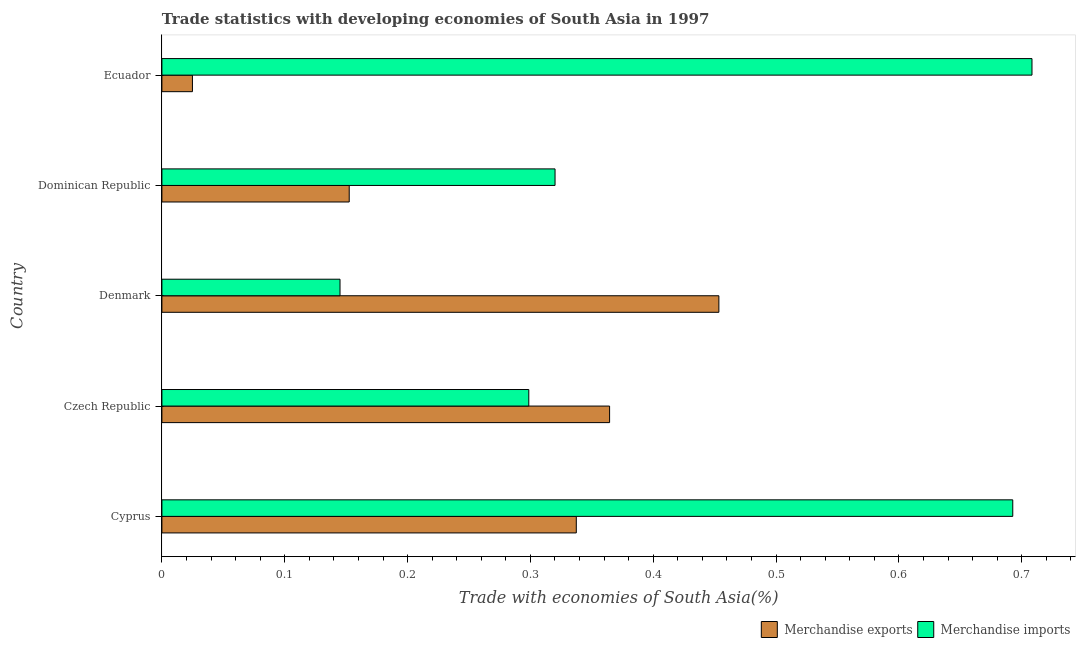How many different coloured bars are there?
Provide a short and direct response. 2. How many groups of bars are there?
Keep it short and to the point. 5. What is the label of the 2nd group of bars from the top?
Provide a succinct answer. Dominican Republic. What is the merchandise imports in Ecuador?
Offer a very short reply. 0.71. Across all countries, what is the maximum merchandise exports?
Offer a terse response. 0.45. Across all countries, what is the minimum merchandise exports?
Make the answer very short. 0.02. In which country was the merchandise imports maximum?
Offer a very short reply. Ecuador. In which country was the merchandise exports minimum?
Offer a terse response. Ecuador. What is the total merchandise imports in the graph?
Your answer should be very brief. 2.16. What is the difference between the merchandise imports in Cyprus and that in Dominican Republic?
Provide a short and direct response. 0.37. What is the difference between the merchandise exports in Czech Republic and the merchandise imports in Dominican Republic?
Provide a succinct answer. 0.04. What is the average merchandise exports per country?
Provide a short and direct response. 0.27. What is the difference between the merchandise imports and merchandise exports in Denmark?
Keep it short and to the point. -0.31. What is the ratio of the merchandise exports in Dominican Republic to that in Ecuador?
Offer a terse response. 6.13. Is the difference between the merchandise imports in Cyprus and Czech Republic greater than the difference between the merchandise exports in Cyprus and Czech Republic?
Ensure brevity in your answer.  Yes. What is the difference between the highest and the second highest merchandise imports?
Offer a terse response. 0.02. What is the difference between the highest and the lowest merchandise imports?
Make the answer very short. 0.56. Is the sum of the merchandise imports in Dominican Republic and Ecuador greater than the maximum merchandise exports across all countries?
Provide a short and direct response. Yes. What does the 2nd bar from the top in Denmark represents?
Provide a succinct answer. Merchandise exports. How many bars are there?
Your answer should be compact. 10. Are all the bars in the graph horizontal?
Your response must be concise. Yes. What is the difference between two consecutive major ticks on the X-axis?
Your answer should be very brief. 0.1. Are the values on the major ticks of X-axis written in scientific E-notation?
Keep it short and to the point. No. Does the graph contain any zero values?
Your answer should be very brief. No. How many legend labels are there?
Ensure brevity in your answer.  2. What is the title of the graph?
Provide a short and direct response. Trade statistics with developing economies of South Asia in 1997. What is the label or title of the X-axis?
Provide a succinct answer. Trade with economies of South Asia(%). What is the label or title of the Y-axis?
Keep it short and to the point. Country. What is the Trade with economies of South Asia(%) of Merchandise exports in Cyprus?
Keep it short and to the point. 0.34. What is the Trade with economies of South Asia(%) in Merchandise imports in Cyprus?
Make the answer very short. 0.69. What is the Trade with economies of South Asia(%) in Merchandise exports in Czech Republic?
Make the answer very short. 0.36. What is the Trade with economies of South Asia(%) in Merchandise imports in Czech Republic?
Provide a succinct answer. 0.3. What is the Trade with economies of South Asia(%) of Merchandise exports in Denmark?
Keep it short and to the point. 0.45. What is the Trade with economies of South Asia(%) in Merchandise imports in Denmark?
Your response must be concise. 0.15. What is the Trade with economies of South Asia(%) of Merchandise exports in Dominican Republic?
Offer a terse response. 0.15. What is the Trade with economies of South Asia(%) in Merchandise imports in Dominican Republic?
Make the answer very short. 0.32. What is the Trade with economies of South Asia(%) of Merchandise exports in Ecuador?
Offer a very short reply. 0.02. What is the Trade with economies of South Asia(%) of Merchandise imports in Ecuador?
Offer a very short reply. 0.71. Across all countries, what is the maximum Trade with economies of South Asia(%) in Merchandise exports?
Ensure brevity in your answer.  0.45. Across all countries, what is the maximum Trade with economies of South Asia(%) of Merchandise imports?
Provide a succinct answer. 0.71. Across all countries, what is the minimum Trade with economies of South Asia(%) in Merchandise exports?
Provide a short and direct response. 0.02. Across all countries, what is the minimum Trade with economies of South Asia(%) of Merchandise imports?
Offer a terse response. 0.15. What is the total Trade with economies of South Asia(%) of Merchandise exports in the graph?
Your answer should be very brief. 1.33. What is the total Trade with economies of South Asia(%) in Merchandise imports in the graph?
Your answer should be compact. 2.16. What is the difference between the Trade with economies of South Asia(%) of Merchandise exports in Cyprus and that in Czech Republic?
Keep it short and to the point. -0.03. What is the difference between the Trade with economies of South Asia(%) of Merchandise imports in Cyprus and that in Czech Republic?
Your response must be concise. 0.39. What is the difference between the Trade with economies of South Asia(%) of Merchandise exports in Cyprus and that in Denmark?
Ensure brevity in your answer.  -0.12. What is the difference between the Trade with economies of South Asia(%) in Merchandise imports in Cyprus and that in Denmark?
Offer a very short reply. 0.55. What is the difference between the Trade with economies of South Asia(%) of Merchandise exports in Cyprus and that in Dominican Republic?
Your answer should be compact. 0.18. What is the difference between the Trade with economies of South Asia(%) of Merchandise imports in Cyprus and that in Dominican Republic?
Your answer should be very brief. 0.37. What is the difference between the Trade with economies of South Asia(%) of Merchandise exports in Cyprus and that in Ecuador?
Make the answer very short. 0.31. What is the difference between the Trade with economies of South Asia(%) of Merchandise imports in Cyprus and that in Ecuador?
Your answer should be very brief. -0.02. What is the difference between the Trade with economies of South Asia(%) in Merchandise exports in Czech Republic and that in Denmark?
Offer a terse response. -0.09. What is the difference between the Trade with economies of South Asia(%) of Merchandise imports in Czech Republic and that in Denmark?
Your answer should be compact. 0.15. What is the difference between the Trade with economies of South Asia(%) of Merchandise exports in Czech Republic and that in Dominican Republic?
Make the answer very short. 0.21. What is the difference between the Trade with economies of South Asia(%) of Merchandise imports in Czech Republic and that in Dominican Republic?
Keep it short and to the point. -0.02. What is the difference between the Trade with economies of South Asia(%) in Merchandise exports in Czech Republic and that in Ecuador?
Provide a short and direct response. 0.34. What is the difference between the Trade with economies of South Asia(%) in Merchandise imports in Czech Republic and that in Ecuador?
Offer a terse response. -0.41. What is the difference between the Trade with economies of South Asia(%) of Merchandise exports in Denmark and that in Dominican Republic?
Make the answer very short. 0.3. What is the difference between the Trade with economies of South Asia(%) in Merchandise imports in Denmark and that in Dominican Republic?
Provide a succinct answer. -0.18. What is the difference between the Trade with economies of South Asia(%) of Merchandise exports in Denmark and that in Ecuador?
Your response must be concise. 0.43. What is the difference between the Trade with economies of South Asia(%) in Merchandise imports in Denmark and that in Ecuador?
Your answer should be very brief. -0.56. What is the difference between the Trade with economies of South Asia(%) of Merchandise exports in Dominican Republic and that in Ecuador?
Offer a terse response. 0.13. What is the difference between the Trade with economies of South Asia(%) of Merchandise imports in Dominican Republic and that in Ecuador?
Provide a short and direct response. -0.39. What is the difference between the Trade with economies of South Asia(%) in Merchandise exports in Cyprus and the Trade with economies of South Asia(%) in Merchandise imports in Czech Republic?
Your answer should be very brief. 0.04. What is the difference between the Trade with economies of South Asia(%) in Merchandise exports in Cyprus and the Trade with economies of South Asia(%) in Merchandise imports in Denmark?
Your response must be concise. 0.19. What is the difference between the Trade with economies of South Asia(%) in Merchandise exports in Cyprus and the Trade with economies of South Asia(%) in Merchandise imports in Dominican Republic?
Give a very brief answer. 0.02. What is the difference between the Trade with economies of South Asia(%) of Merchandise exports in Cyprus and the Trade with economies of South Asia(%) of Merchandise imports in Ecuador?
Make the answer very short. -0.37. What is the difference between the Trade with economies of South Asia(%) of Merchandise exports in Czech Republic and the Trade with economies of South Asia(%) of Merchandise imports in Denmark?
Your answer should be compact. 0.22. What is the difference between the Trade with economies of South Asia(%) in Merchandise exports in Czech Republic and the Trade with economies of South Asia(%) in Merchandise imports in Dominican Republic?
Make the answer very short. 0.04. What is the difference between the Trade with economies of South Asia(%) of Merchandise exports in Czech Republic and the Trade with economies of South Asia(%) of Merchandise imports in Ecuador?
Give a very brief answer. -0.34. What is the difference between the Trade with economies of South Asia(%) in Merchandise exports in Denmark and the Trade with economies of South Asia(%) in Merchandise imports in Dominican Republic?
Keep it short and to the point. 0.13. What is the difference between the Trade with economies of South Asia(%) of Merchandise exports in Denmark and the Trade with economies of South Asia(%) of Merchandise imports in Ecuador?
Provide a succinct answer. -0.25. What is the difference between the Trade with economies of South Asia(%) in Merchandise exports in Dominican Republic and the Trade with economies of South Asia(%) in Merchandise imports in Ecuador?
Your answer should be very brief. -0.56. What is the average Trade with economies of South Asia(%) of Merchandise exports per country?
Your response must be concise. 0.27. What is the average Trade with economies of South Asia(%) in Merchandise imports per country?
Your response must be concise. 0.43. What is the difference between the Trade with economies of South Asia(%) in Merchandise exports and Trade with economies of South Asia(%) in Merchandise imports in Cyprus?
Your answer should be compact. -0.36. What is the difference between the Trade with economies of South Asia(%) in Merchandise exports and Trade with economies of South Asia(%) in Merchandise imports in Czech Republic?
Provide a short and direct response. 0.07. What is the difference between the Trade with economies of South Asia(%) of Merchandise exports and Trade with economies of South Asia(%) of Merchandise imports in Denmark?
Make the answer very short. 0.31. What is the difference between the Trade with economies of South Asia(%) of Merchandise exports and Trade with economies of South Asia(%) of Merchandise imports in Dominican Republic?
Your answer should be very brief. -0.17. What is the difference between the Trade with economies of South Asia(%) of Merchandise exports and Trade with economies of South Asia(%) of Merchandise imports in Ecuador?
Ensure brevity in your answer.  -0.68. What is the ratio of the Trade with economies of South Asia(%) in Merchandise exports in Cyprus to that in Czech Republic?
Give a very brief answer. 0.93. What is the ratio of the Trade with economies of South Asia(%) of Merchandise imports in Cyprus to that in Czech Republic?
Give a very brief answer. 2.32. What is the ratio of the Trade with economies of South Asia(%) of Merchandise exports in Cyprus to that in Denmark?
Give a very brief answer. 0.74. What is the ratio of the Trade with economies of South Asia(%) in Merchandise imports in Cyprus to that in Denmark?
Make the answer very short. 4.78. What is the ratio of the Trade with economies of South Asia(%) in Merchandise exports in Cyprus to that in Dominican Republic?
Your answer should be compact. 2.21. What is the ratio of the Trade with economies of South Asia(%) of Merchandise imports in Cyprus to that in Dominican Republic?
Provide a succinct answer. 2.16. What is the ratio of the Trade with economies of South Asia(%) of Merchandise exports in Cyprus to that in Ecuador?
Your response must be concise. 13.57. What is the ratio of the Trade with economies of South Asia(%) in Merchandise imports in Cyprus to that in Ecuador?
Offer a terse response. 0.98. What is the ratio of the Trade with economies of South Asia(%) in Merchandise exports in Czech Republic to that in Denmark?
Offer a very short reply. 0.8. What is the ratio of the Trade with economies of South Asia(%) of Merchandise imports in Czech Republic to that in Denmark?
Give a very brief answer. 2.06. What is the ratio of the Trade with economies of South Asia(%) of Merchandise exports in Czech Republic to that in Dominican Republic?
Your answer should be very brief. 2.39. What is the ratio of the Trade with economies of South Asia(%) of Merchandise imports in Czech Republic to that in Dominican Republic?
Your answer should be compact. 0.93. What is the ratio of the Trade with economies of South Asia(%) of Merchandise exports in Czech Republic to that in Ecuador?
Keep it short and to the point. 14.66. What is the ratio of the Trade with economies of South Asia(%) in Merchandise imports in Czech Republic to that in Ecuador?
Make the answer very short. 0.42. What is the ratio of the Trade with economies of South Asia(%) of Merchandise exports in Denmark to that in Dominican Republic?
Your answer should be compact. 2.97. What is the ratio of the Trade with economies of South Asia(%) of Merchandise imports in Denmark to that in Dominican Republic?
Provide a short and direct response. 0.45. What is the ratio of the Trade with economies of South Asia(%) of Merchandise exports in Denmark to that in Ecuador?
Your response must be concise. 18.24. What is the ratio of the Trade with economies of South Asia(%) in Merchandise imports in Denmark to that in Ecuador?
Keep it short and to the point. 0.2. What is the ratio of the Trade with economies of South Asia(%) in Merchandise exports in Dominican Republic to that in Ecuador?
Give a very brief answer. 6.13. What is the ratio of the Trade with economies of South Asia(%) of Merchandise imports in Dominican Republic to that in Ecuador?
Your answer should be compact. 0.45. What is the difference between the highest and the second highest Trade with economies of South Asia(%) in Merchandise exports?
Keep it short and to the point. 0.09. What is the difference between the highest and the second highest Trade with economies of South Asia(%) in Merchandise imports?
Ensure brevity in your answer.  0.02. What is the difference between the highest and the lowest Trade with economies of South Asia(%) in Merchandise exports?
Your response must be concise. 0.43. What is the difference between the highest and the lowest Trade with economies of South Asia(%) of Merchandise imports?
Make the answer very short. 0.56. 